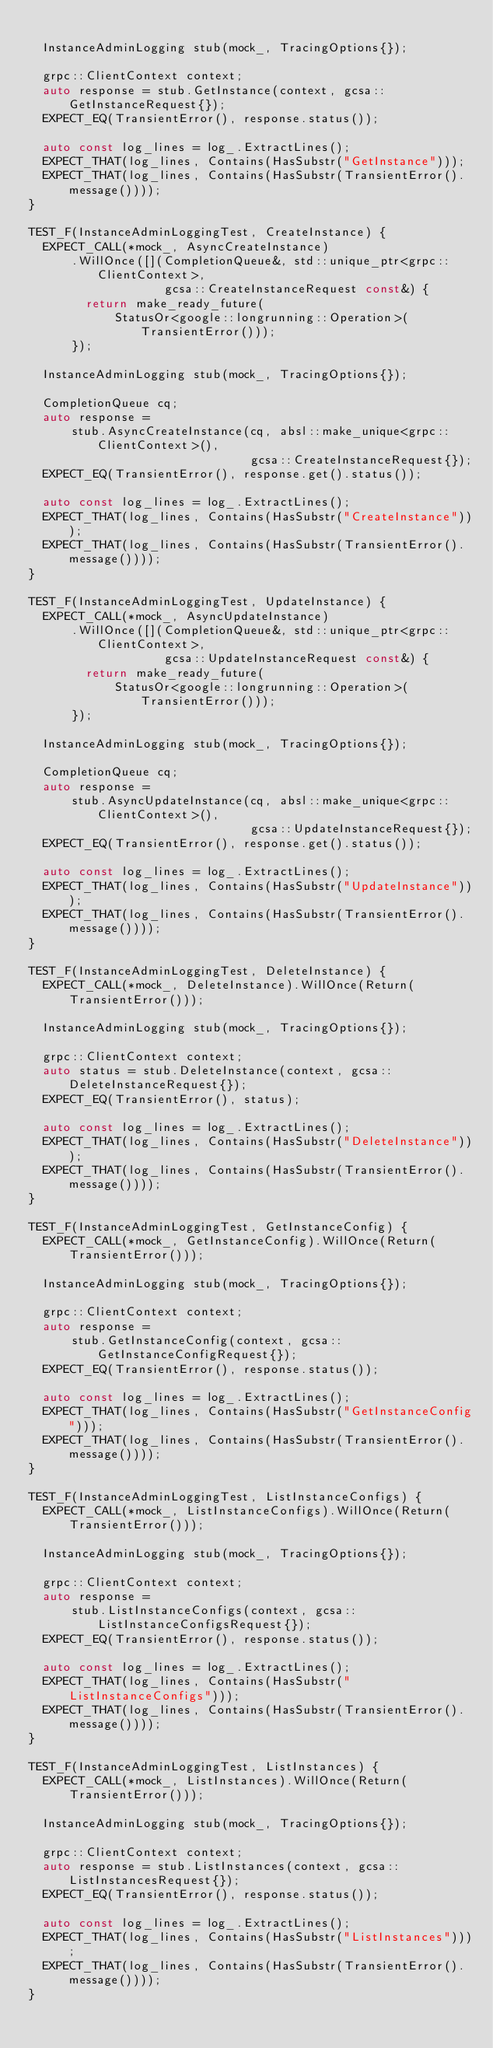<code> <loc_0><loc_0><loc_500><loc_500><_C++_>
  InstanceAdminLogging stub(mock_, TracingOptions{});

  grpc::ClientContext context;
  auto response = stub.GetInstance(context, gcsa::GetInstanceRequest{});
  EXPECT_EQ(TransientError(), response.status());

  auto const log_lines = log_.ExtractLines();
  EXPECT_THAT(log_lines, Contains(HasSubstr("GetInstance")));
  EXPECT_THAT(log_lines, Contains(HasSubstr(TransientError().message())));
}

TEST_F(InstanceAdminLoggingTest, CreateInstance) {
  EXPECT_CALL(*mock_, AsyncCreateInstance)
      .WillOnce([](CompletionQueue&, std::unique_ptr<grpc::ClientContext>,
                   gcsa::CreateInstanceRequest const&) {
        return make_ready_future(
            StatusOr<google::longrunning::Operation>(TransientError()));
      });

  InstanceAdminLogging stub(mock_, TracingOptions{});

  CompletionQueue cq;
  auto response =
      stub.AsyncCreateInstance(cq, absl::make_unique<grpc::ClientContext>(),
                               gcsa::CreateInstanceRequest{});
  EXPECT_EQ(TransientError(), response.get().status());

  auto const log_lines = log_.ExtractLines();
  EXPECT_THAT(log_lines, Contains(HasSubstr("CreateInstance")));
  EXPECT_THAT(log_lines, Contains(HasSubstr(TransientError().message())));
}

TEST_F(InstanceAdminLoggingTest, UpdateInstance) {
  EXPECT_CALL(*mock_, AsyncUpdateInstance)
      .WillOnce([](CompletionQueue&, std::unique_ptr<grpc::ClientContext>,
                   gcsa::UpdateInstanceRequest const&) {
        return make_ready_future(
            StatusOr<google::longrunning::Operation>(TransientError()));
      });

  InstanceAdminLogging stub(mock_, TracingOptions{});

  CompletionQueue cq;
  auto response =
      stub.AsyncUpdateInstance(cq, absl::make_unique<grpc::ClientContext>(),
                               gcsa::UpdateInstanceRequest{});
  EXPECT_EQ(TransientError(), response.get().status());

  auto const log_lines = log_.ExtractLines();
  EXPECT_THAT(log_lines, Contains(HasSubstr("UpdateInstance")));
  EXPECT_THAT(log_lines, Contains(HasSubstr(TransientError().message())));
}

TEST_F(InstanceAdminLoggingTest, DeleteInstance) {
  EXPECT_CALL(*mock_, DeleteInstance).WillOnce(Return(TransientError()));

  InstanceAdminLogging stub(mock_, TracingOptions{});

  grpc::ClientContext context;
  auto status = stub.DeleteInstance(context, gcsa::DeleteInstanceRequest{});
  EXPECT_EQ(TransientError(), status);

  auto const log_lines = log_.ExtractLines();
  EXPECT_THAT(log_lines, Contains(HasSubstr("DeleteInstance")));
  EXPECT_THAT(log_lines, Contains(HasSubstr(TransientError().message())));
}

TEST_F(InstanceAdminLoggingTest, GetInstanceConfig) {
  EXPECT_CALL(*mock_, GetInstanceConfig).WillOnce(Return(TransientError()));

  InstanceAdminLogging stub(mock_, TracingOptions{});

  grpc::ClientContext context;
  auto response =
      stub.GetInstanceConfig(context, gcsa::GetInstanceConfigRequest{});
  EXPECT_EQ(TransientError(), response.status());

  auto const log_lines = log_.ExtractLines();
  EXPECT_THAT(log_lines, Contains(HasSubstr("GetInstanceConfig")));
  EXPECT_THAT(log_lines, Contains(HasSubstr(TransientError().message())));
}

TEST_F(InstanceAdminLoggingTest, ListInstanceConfigs) {
  EXPECT_CALL(*mock_, ListInstanceConfigs).WillOnce(Return(TransientError()));

  InstanceAdminLogging stub(mock_, TracingOptions{});

  grpc::ClientContext context;
  auto response =
      stub.ListInstanceConfigs(context, gcsa::ListInstanceConfigsRequest{});
  EXPECT_EQ(TransientError(), response.status());

  auto const log_lines = log_.ExtractLines();
  EXPECT_THAT(log_lines, Contains(HasSubstr("ListInstanceConfigs")));
  EXPECT_THAT(log_lines, Contains(HasSubstr(TransientError().message())));
}

TEST_F(InstanceAdminLoggingTest, ListInstances) {
  EXPECT_CALL(*mock_, ListInstances).WillOnce(Return(TransientError()));

  InstanceAdminLogging stub(mock_, TracingOptions{});

  grpc::ClientContext context;
  auto response = stub.ListInstances(context, gcsa::ListInstancesRequest{});
  EXPECT_EQ(TransientError(), response.status());

  auto const log_lines = log_.ExtractLines();
  EXPECT_THAT(log_lines, Contains(HasSubstr("ListInstances")));
  EXPECT_THAT(log_lines, Contains(HasSubstr(TransientError().message())));
}
</code> 